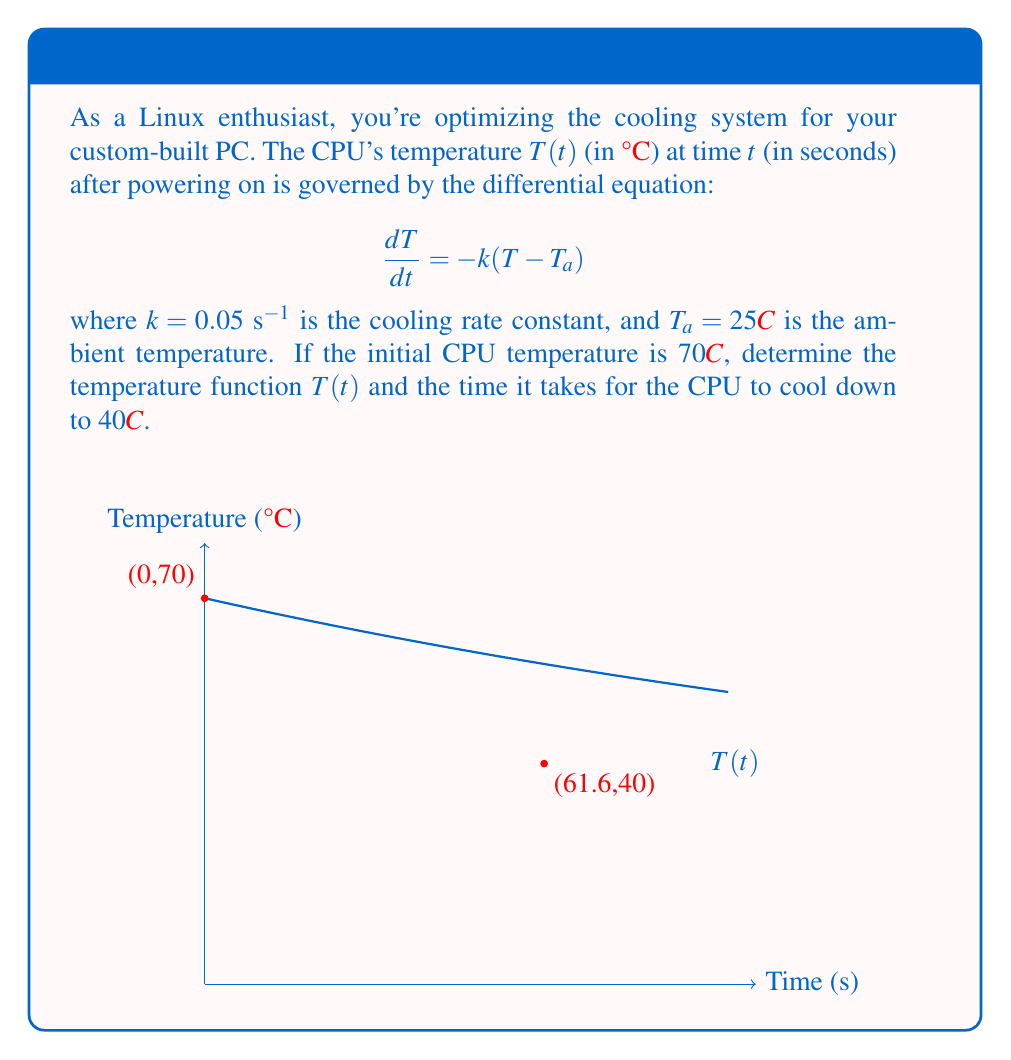Can you answer this question? Let's solve this step-by-step:

1) The general form of the differential equation is:
   $$\frac{dT}{dt} = -k(T - T_a)$$

2) This is a first-order linear differential equation. The solution has the form:
   $$T(t) = T_a + Ce^{-kt}$$
   where $C$ is a constant to be determined.

3) We know the initial condition: $T(0) = 70°C$. Let's substitute this:
   $$70 = 25 + C$$
   $$C = 45$$

4) Therefore, the temperature function is:
   $$T(t) = 25 + 45e^{-0.05t}$$

5) To find when the CPU cools to 40°C, we solve:
   $$40 = 25 + 45e^{-0.05t}$$
   $$15 = 45e^{-0.05t}$$
   $$\frac{1}{3} = e^{-0.05t}$$
   $$\ln(\frac{1}{3}) = -0.05t$$
   $$t = \frac{-\ln(\frac{1}{3})}{0.05} \approx 61.6\text{ seconds}$$

Thus, it takes approximately 61.6 seconds for the CPU to cool from 70°C to 40°C.
Answer: $T(t) = 25 + 45e^{-0.05t}$; 61.6 seconds 